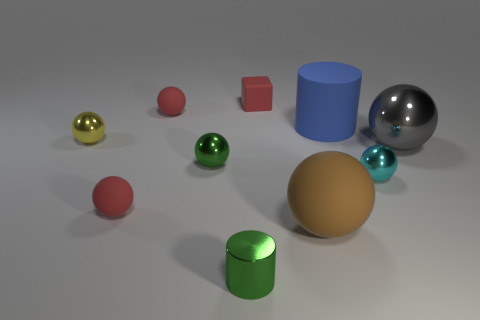Subtract all red spheres. How many spheres are left? 5 Subtract all small cyan balls. How many balls are left? 6 Subtract all gray spheres. Subtract all yellow cylinders. How many spheres are left? 6 Subtract all cubes. How many objects are left? 9 Subtract 1 red cubes. How many objects are left? 9 Subtract all small red things. Subtract all gray balls. How many objects are left? 6 Add 9 big cylinders. How many big cylinders are left? 10 Add 5 green cylinders. How many green cylinders exist? 6 